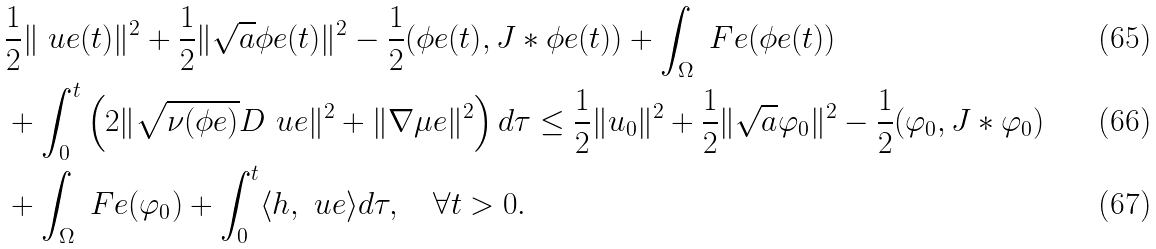<formula> <loc_0><loc_0><loc_500><loc_500>& \frac { 1 } { 2 } \| \ u e ( t ) \| ^ { 2 } + \frac { 1 } { 2 } \| \sqrt { a } \phi e ( t ) \| ^ { 2 } - \frac { 1 } { 2 } ( \phi e ( t ) , J \ast \phi e ( t ) ) + \int _ { \Omega } \ F e ( \phi e ( t ) ) \\ & + \int _ { 0 } ^ { t } \left ( 2 \| \sqrt { \nu ( \phi e ) } D \ u e \| ^ { 2 } + \| \nabla \mu e \| ^ { 2 } \right ) d \tau \leq \frac { 1 } { 2 } \| u _ { 0 } \| ^ { 2 } + \frac { 1 } { 2 } \| \sqrt { a } \varphi _ { 0 } \| ^ { 2 } - \frac { 1 } { 2 } ( \varphi _ { 0 } , J \ast \varphi _ { 0 } ) \\ & + \int _ { \Omega } \ F e ( \varphi _ { 0 } ) + \int _ { 0 } ^ { t } \langle h , \ u e \rangle d \tau , \quad \forall t > 0 .</formula> 